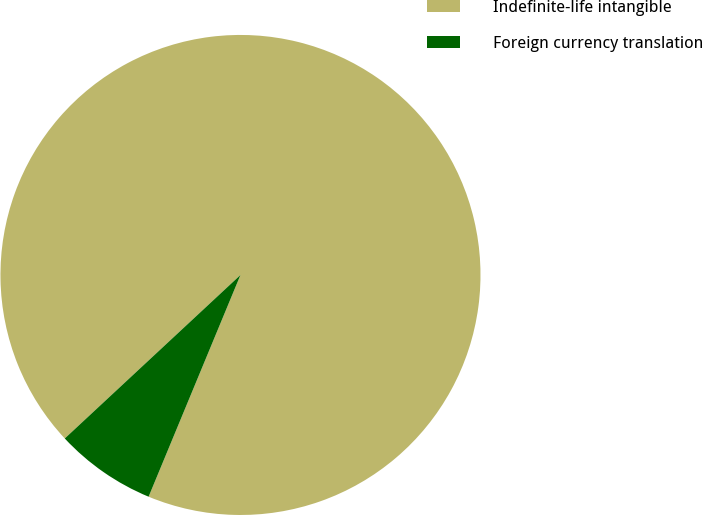Convert chart. <chart><loc_0><loc_0><loc_500><loc_500><pie_chart><fcel>Indefinite-life intangible<fcel>Foreign currency translation<nl><fcel>93.18%<fcel>6.82%<nl></chart> 